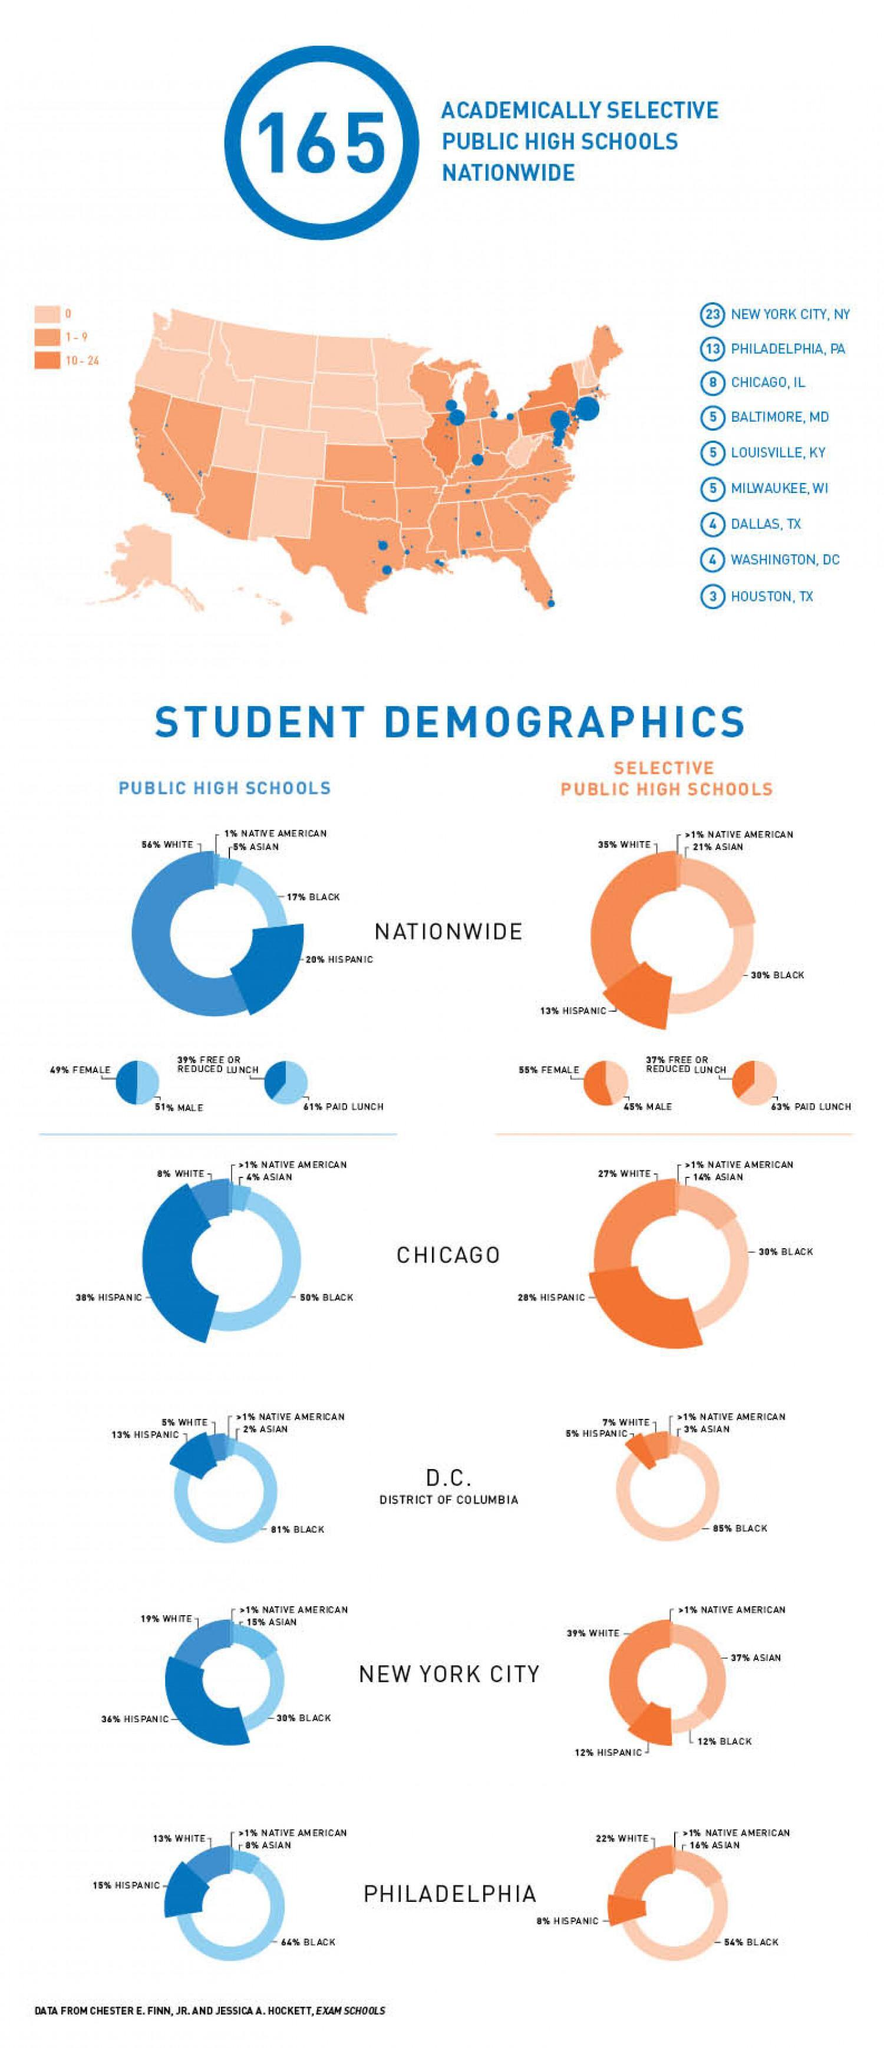How many academically selective public high schools from Houston?
Answer the question with a short phrase. 3 What percentage of students are female in nationwide selective public high schools? 55% In nationwide public schools, what percentage has to pay for lunch? 61% What percentage of students are Hispanic in selective public high schools in Philadelphia? 8% Which group is minority in nationwide public high schools? NATIVE AMERICAN Which community is second in number in selective public high schools in New York City? ASIAN 